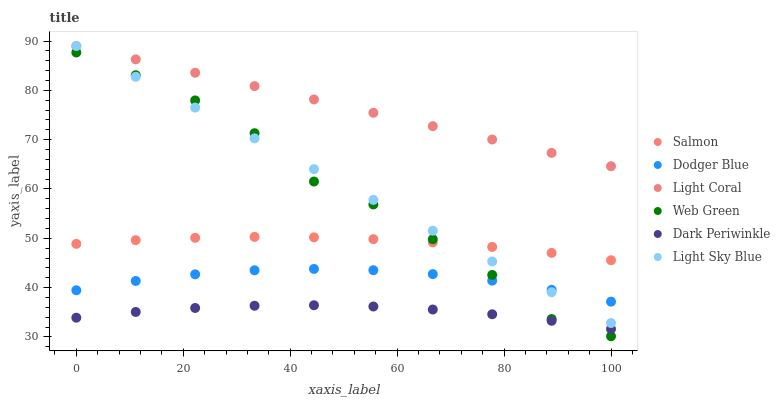Does Dark Periwinkle have the minimum area under the curve?
Answer yes or no. Yes. Does Light Coral have the maximum area under the curve?
Answer yes or no. Yes. Does Web Green have the minimum area under the curve?
Answer yes or no. No. Does Web Green have the maximum area under the curve?
Answer yes or no. No. Is Light Sky Blue the smoothest?
Answer yes or no. Yes. Is Web Green the roughest?
Answer yes or no. Yes. Is Light Coral the smoothest?
Answer yes or no. No. Is Light Coral the roughest?
Answer yes or no. No. Does Web Green have the lowest value?
Answer yes or no. Yes. Does Light Coral have the lowest value?
Answer yes or no. No. Does Light Sky Blue have the highest value?
Answer yes or no. Yes. Does Web Green have the highest value?
Answer yes or no. No. Is Dodger Blue less than Salmon?
Answer yes or no. Yes. Is Salmon greater than Dodger Blue?
Answer yes or no. Yes. Does Dodger Blue intersect Light Sky Blue?
Answer yes or no. Yes. Is Dodger Blue less than Light Sky Blue?
Answer yes or no. No. Is Dodger Blue greater than Light Sky Blue?
Answer yes or no. No. Does Dodger Blue intersect Salmon?
Answer yes or no. No. 